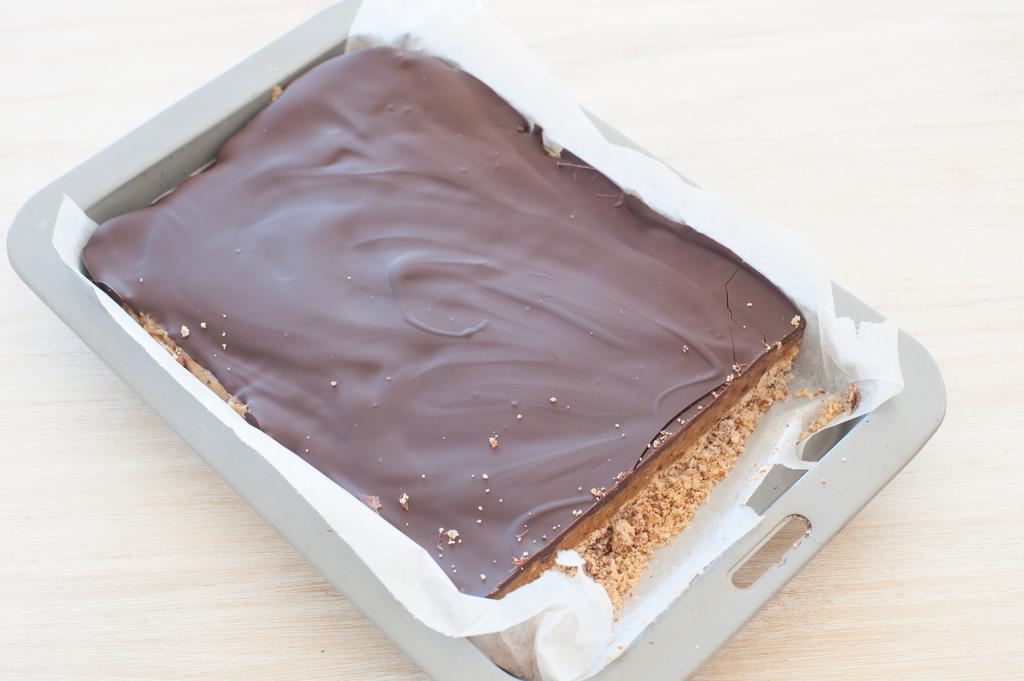Please provide a concise description of this image. In this image we can see tray on a wooden surface. In the trap we can see butter paper with cake. 